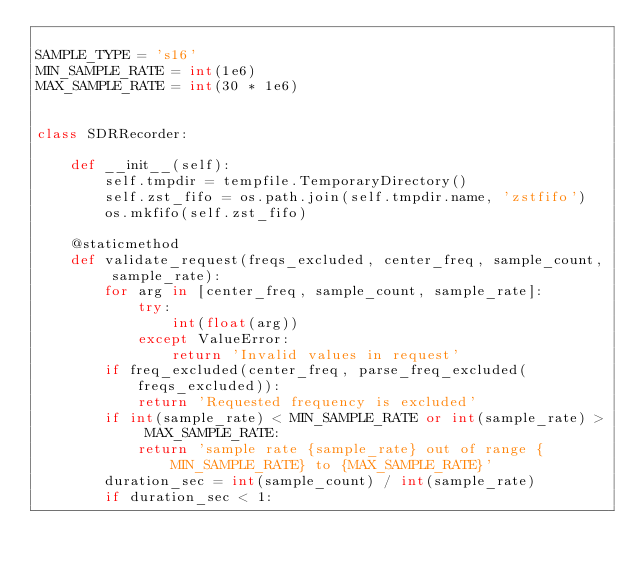Convert code to text. <code><loc_0><loc_0><loc_500><loc_500><_Python_>
SAMPLE_TYPE = 's16'
MIN_SAMPLE_RATE = int(1e6)
MAX_SAMPLE_RATE = int(30 * 1e6)


class SDRRecorder:

    def __init__(self):
        self.tmpdir = tempfile.TemporaryDirectory()
        self.zst_fifo = os.path.join(self.tmpdir.name, 'zstfifo')
        os.mkfifo(self.zst_fifo)

    @staticmethod
    def validate_request(freqs_excluded, center_freq, sample_count, sample_rate):
        for arg in [center_freq, sample_count, sample_rate]:
            try:
                int(float(arg))
            except ValueError:
                return 'Invalid values in request'
        if freq_excluded(center_freq, parse_freq_excluded(freqs_excluded)):
            return 'Requested frequency is excluded'
        if int(sample_rate) < MIN_SAMPLE_RATE or int(sample_rate) > MAX_SAMPLE_RATE:
            return 'sample rate {sample_rate} out of range {MIN_SAMPLE_RATE} to {MAX_SAMPLE_RATE}'
        duration_sec = int(sample_count) / int(sample_rate)
        if duration_sec < 1:</code> 